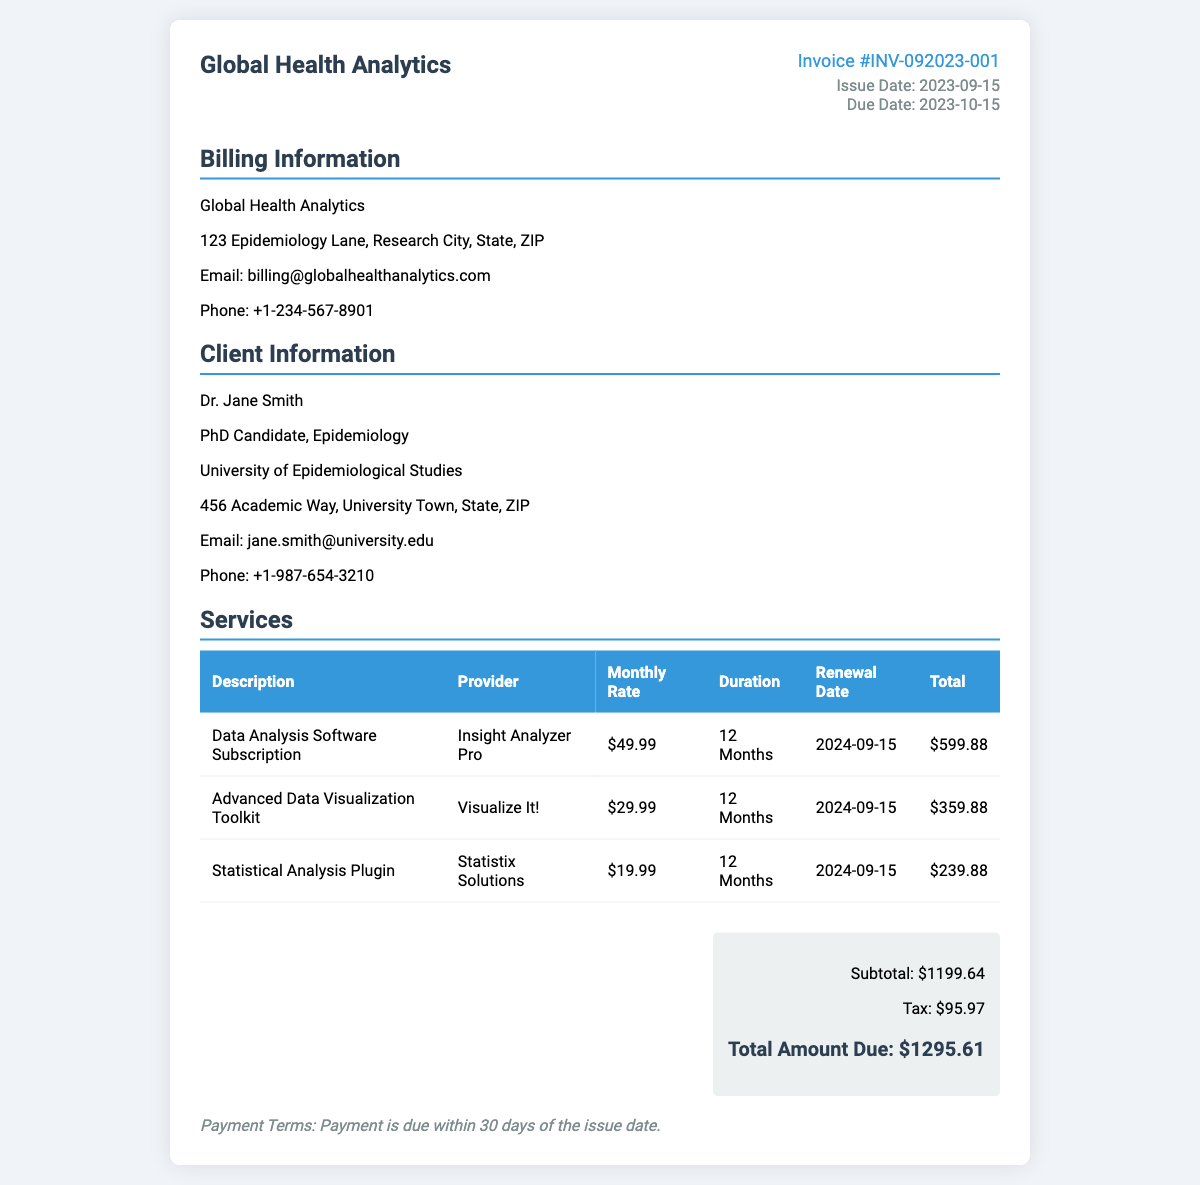what is the invoice number? The invoice number is a unique identifier for this transaction, found under the invoice details section.
Answer: INV-092023-001 who is the service provider for the Data Analysis Software Subscription? The service provider's name is listed in the services section alongside the description of the service.
Answer: Insight Analyzer Pro what is the total amount due? The total amount due represents the final cost after taxes and is found in the total section.
Answer: $1295.61 when is the renewal date for the Advanced Data Visualization Toolkit? The renewal date is specified in the services section for each service.
Answer: 2024-09-15 how much is the tax applied to the subtotal? The tax amount is shown in the total section and is the additional cost added to the subtotal.
Answer: $95.97 what is the duration of the Statistical Analysis Plugin subscription? The duration is specified in the services section and indicates how long the subscription lasts.
Answer: 12 Months how many services are listed in the invoice? The total number of services is represented by the number of rows in the services table minus the header row.
Answer: 3 what is the payment terms stated in the invoice? The payment terms provide conditions on when the payment is due, which is mentioned at the bottom of the document.
Answer: Payment is due within 30 days of the issue date who is the client listed in the invoice? The client's details are present in the client information section of the document.
Answer: Dr. Jane Smith 